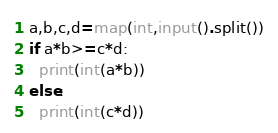<code> <loc_0><loc_0><loc_500><loc_500><_Python_>a,b,c,d=map(int,input().split())
if a*b>=c*d:
  print(int(a*b))
else:
  print(int(c*d))</code> 